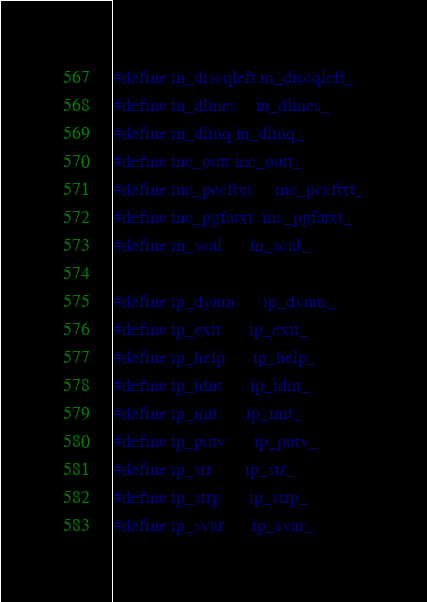<code> <loc_0><loc_0><loc_500><loc_500><_C_>#define in_discqleft	in_discqleft_
#define in_dlines	in_dlines_
#define in_dlinq	in_dlinq_
#define inc_outt	inc_outt_
#define inc_pccftxt     inc_pccftxt_
#define inc_pgfatxt	inc_pgfatxt_
#define in_scal		in_scal_

#define ip_dynm		ip_dynm_
#define ip_exit		ip_exit_
#define ip_help		ip_help_
#define ip_idnt		ip_idnt_
#define ip_init		ip_init_
#define ip_putv		ip_putv_
#define ip_str		ip_str_
#define ip_strp		ip_strp_
#define ip_svar		ip_svar_</code> 